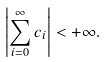Convert formula to latex. <formula><loc_0><loc_0><loc_500><loc_500>\left | \sum _ { i = 0 } ^ { \infty } c _ { i } \right | < + \infty .</formula> 